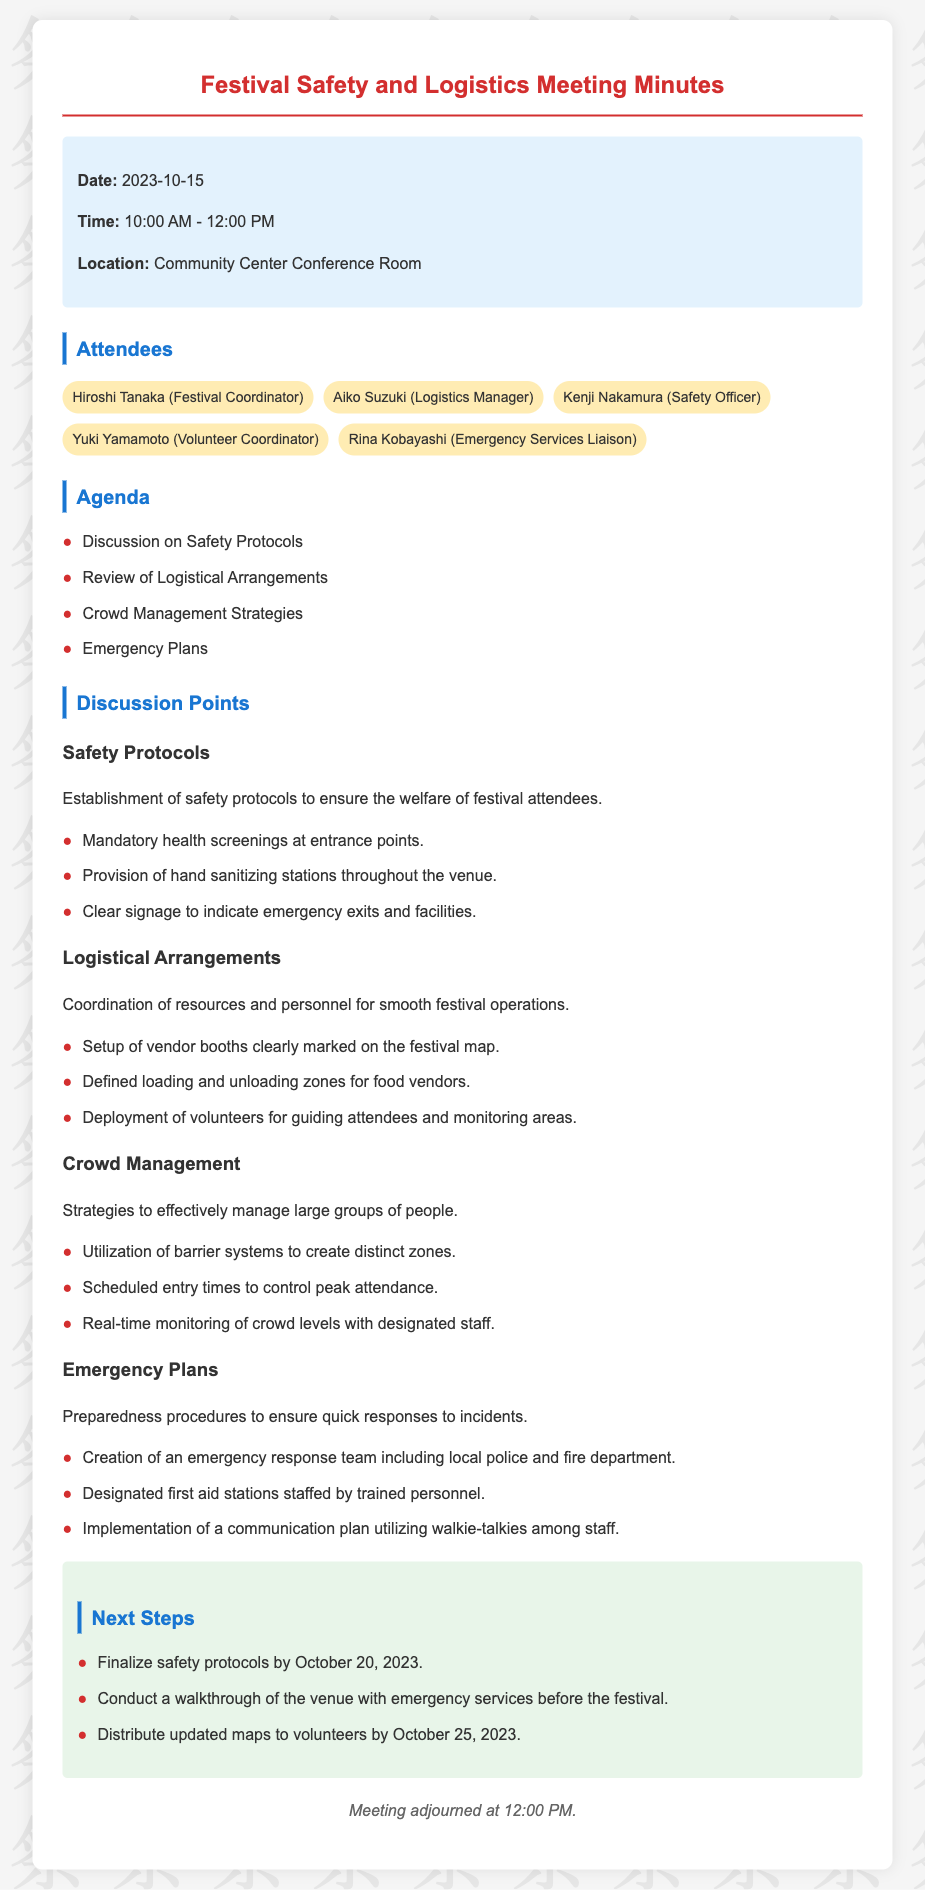What is the meeting date? The meeting date is specified in the document under the info section.
Answer: 2023-10-15 Who is the Safety Officer? The Safety Officer's name is listed among the attendees.
Answer: Kenji Nakamura What is one of the safety protocols established? The safety protocols are outlined in the discussion points section.
Answer: Mandatory health screenings at entrance points What is the purpose of the emergency response team? The purpose is mentioned in the emergency plans section, summarizing their function.
Answer: Quick responses to incidents What is a crowd management strategy mentioned? A specific strategy is detailed in the crowd management section of the document.
Answer: Utilization of barrier systems to create distinct zones When are the finalized safety protocols due? The deadline for finalizing the safety protocols is stated in the next steps section.
Answer: October 20, 2023 How many attendees were at the meeting? The total number of attendees is indicated in the attendees section.
Answer: Five What will be distributed to volunteers by October 25, 2023? This action is defined in the next steps section of the document.
Answer: Updated maps What type of stations will be designated for first aid? This detail is included in the emergency plans discussion.
Answer: First aid stations staffed by trained personnel 